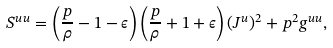Convert formula to latex. <formula><loc_0><loc_0><loc_500><loc_500>S ^ { u u } = \left ( \frac { p } { \rho } - 1 - \epsilon \right ) \left ( \frac { p } { \rho } + 1 + \epsilon \right ) ( J ^ { u } ) ^ { 2 } + p ^ { 2 } g ^ { u u } ,</formula> 